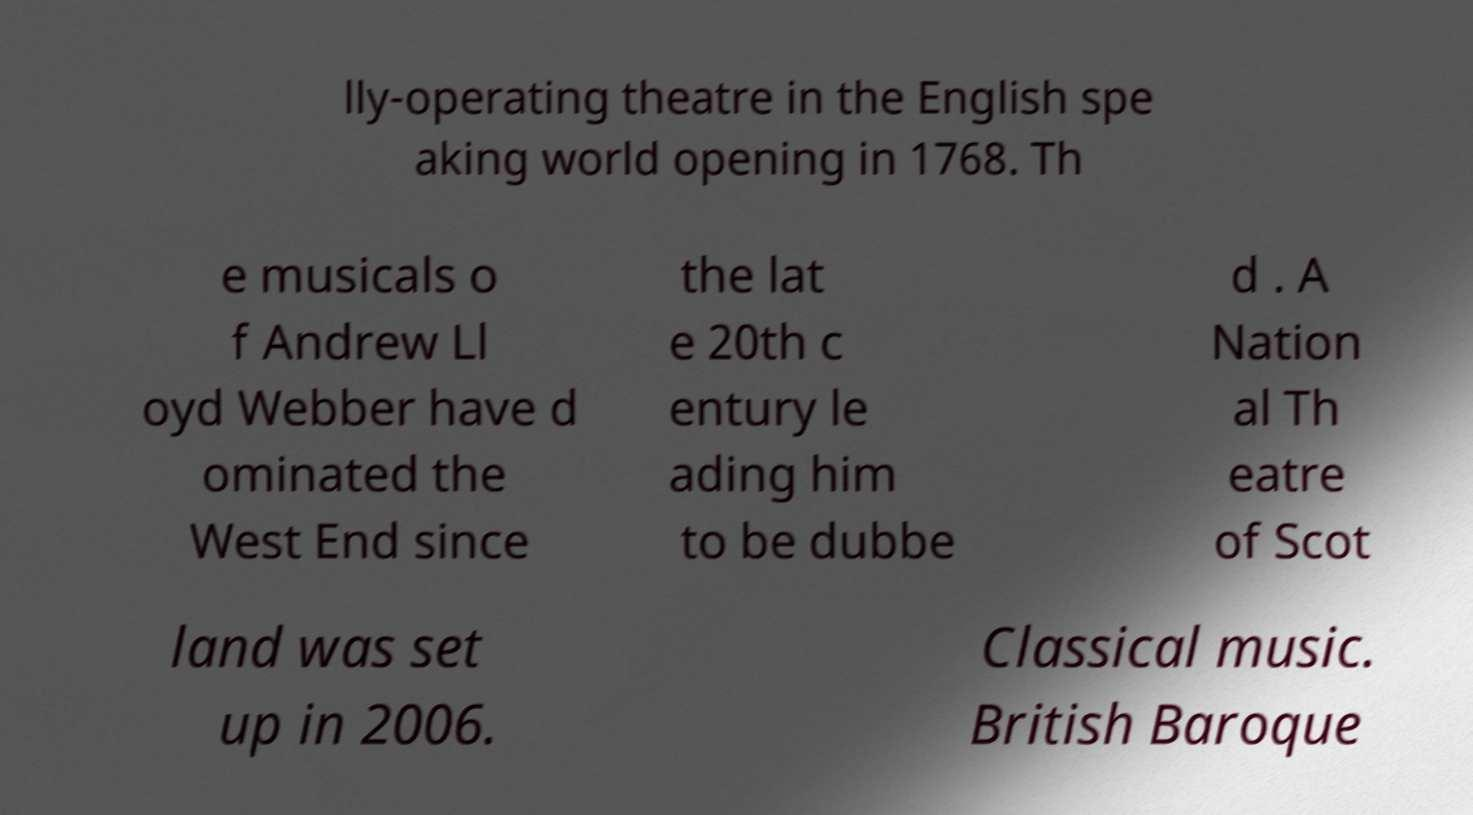Can you accurately transcribe the text from the provided image for me? lly-operating theatre in the English spe aking world opening in 1768. Th e musicals o f Andrew Ll oyd Webber have d ominated the West End since the lat e 20th c entury le ading him to be dubbe d . A Nation al Th eatre of Scot land was set up in 2006. Classical music. British Baroque 